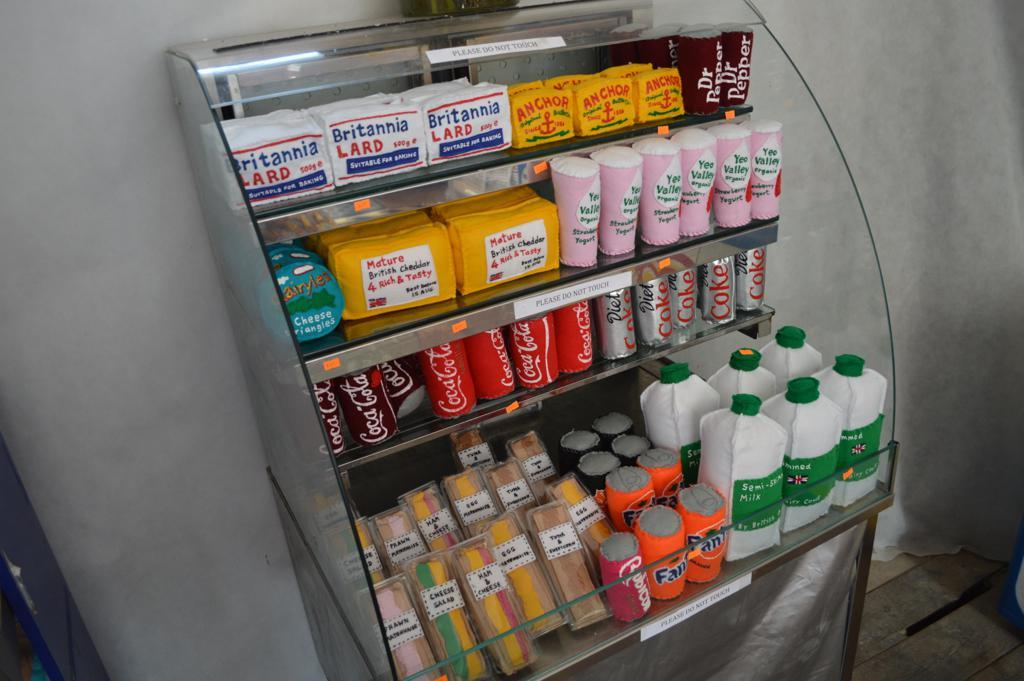<image>
Describe the image concisely. A refrigerated case features lard, drinks and sandwiches, among its wares. 